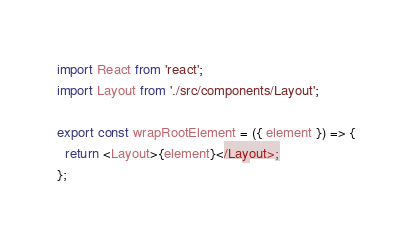<code> <loc_0><loc_0><loc_500><loc_500><_JavaScript_>
import React from 'react';
import Layout from './src/components/Layout';

export const wrapRootElement = ({ element }) => {
  return <Layout>{element}</Layout>;
};
</code> 